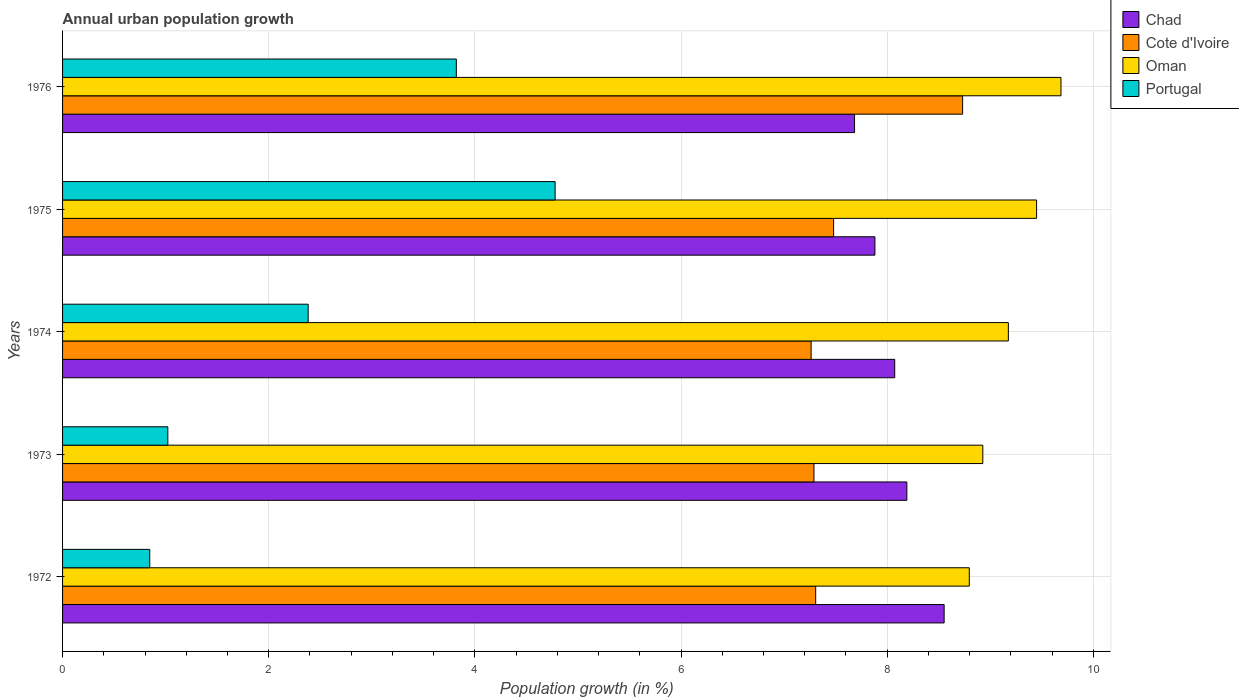How many different coloured bars are there?
Provide a short and direct response. 4. How many bars are there on the 3rd tick from the top?
Your answer should be very brief. 4. In how many cases, is the number of bars for a given year not equal to the number of legend labels?
Keep it short and to the point. 0. What is the percentage of urban population growth in Chad in 1973?
Your response must be concise. 8.19. Across all years, what is the maximum percentage of urban population growth in Cote d'Ivoire?
Your answer should be very brief. 8.73. Across all years, what is the minimum percentage of urban population growth in Chad?
Give a very brief answer. 7.68. In which year was the percentage of urban population growth in Cote d'Ivoire maximum?
Give a very brief answer. 1976. In which year was the percentage of urban population growth in Portugal minimum?
Your answer should be compact. 1972. What is the total percentage of urban population growth in Chad in the graph?
Give a very brief answer. 40.38. What is the difference between the percentage of urban population growth in Chad in 1972 and that in 1976?
Make the answer very short. 0.87. What is the difference between the percentage of urban population growth in Cote d'Ivoire in 1973 and the percentage of urban population growth in Chad in 1975?
Make the answer very short. -0.59. What is the average percentage of urban population growth in Chad per year?
Make the answer very short. 8.08. In the year 1974, what is the difference between the percentage of urban population growth in Cote d'Ivoire and percentage of urban population growth in Oman?
Your answer should be very brief. -1.91. In how many years, is the percentage of urban population growth in Oman greater than 7.2 %?
Give a very brief answer. 5. What is the ratio of the percentage of urban population growth in Oman in 1975 to that in 1976?
Offer a terse response. 0.98. Is the percentage of urban population growth in Oman in 1972 less than that in 1976?
Ensure brevity in your answer.  Yes. What is the difference between the highest and the second highest percentage of urban population growth in Portugal?
Your answer should be very brief. 0.96. What is the difference between the highest and the lowest percentage of urban population growth in Portugal?
Give a very brief answer. 3.93. Is the sum of the percentage of urban population growth in Portugal in 1972 and 1973 greater than the maximum percentage of urban population growth in Chad across all years?
Make the answer very short. No. What does the 3rd bar from the top in 1976 represents?
Ensure brevity in your answer.  Cote d'Ivoire. What does the 4th bar from the bottom in 1974 represents?
Provide a succinct answer. Portugal. Are all the bars in the graph horizontal?
Your response must be concise. Yes. How many years are there in the graph?
Your answer should be very brief. 5. Are the values on the major ticks of X-axis written in scientific E-notation?
Your answer should be very brief. No. Does the graph contain any zero values?
Keep it short and to the point. No. Does the graph contain grids?
Your answer should be compact. Yes. How many legend labels are there?
Your answer should be compact. 4. How are the legend labels stacked?
Provide a short and direct response. Vertical. What is the title of the graph?
Make the answer very short. Annual urban population growth. What is the label or title of the X-axis?
Make the answer very short. Population growth (in %). What is the Population growth (in %) of Chad in 1972?
Make the answer very short. 8.55. What is the Population growth (in %) of Cote d'Ivoire in 1972?
Offer a very short reply. 7.31. What is the Population growth (in %) in Oman in 1972?
Keep it short and to the point. 8.8. What is the Population growth (in %) in Portugal in 1972?
Make the answer very short. 0.85. What is the Population growth (in %) of Chad in 1973?
Your response must be concise. 8.19. What is the Population growth (in %) of Cote d'Ivoire in 1973?
Your response must be concise. 7.29. What is the Population growth (in %) in Oman in 1973?
Provide a succinct answer. 8.93. What is the Population growth (in %) in Portugal in 1973?
Provide a succinct answer. 1.02. What is the Population growth (in %) of Chad in 1974?
Your answer should be very brief. 8.07. What is the Population growth (in %) in Cote d'Ivoire in 1974?
Offer a very short reply. 7.26. What is the Population growth (in %) in Oman in 1974?
Your response must be concise. 9.18. What is the Population growth (in %) of Portugal in 1974?
Your answer should be very brief. 2.38. What is the Population growth (in %) of Chad in 1975?
Make the answer very short. 7.88. What is the Population growth (in %) in Cote d'Ivoire in 1975?
Offer a very short reply. 7.48. What is the Population growth (in %) of Oman in 1975?
Your response must be concise. 9.45. What is the Population growth (in %) in Portugal in 1975?
Make the answer very short. 4.78. What is the Population growth (in %) in Chad in 1976?
Give a very brief answer. 7.68. What is the Population growth (in %) in Cote d'Ivoire in 1976?
Give a very brief answer. 8.73. What is the Population growth (in %) of Oman in 1976?
Ensure brevity in your answer.  9.69. What is the Population growth (in %) in Portugal in 1976?
Provide a short and direct response. 3.82. Across all years, what is the maximum Population growth (in %) of Chad?
Offer a terse response. 8.55. Across all years, what is the maximum Population growth (in %) of Cote d'Ivoire?
Provide a short and direct response. 8.73. Across all years, what is the maximum Population growth (in %) in Oman?
Your answer should be compact. 9.69. Across all years, what is the maximum Population growth (in %) of Portugal?
Your answer should be compact. 4.78. Across all years, what is the minimum Population growth (in %) in Chad?
Offer a terse response. 7.68. Across all years, what is the minimum Population growth (in %) in Cote d'Ivoire?
Provide a succinct answer. 7.26. Across all years, what is the minimum Population growth (in %) of Oman?
Provide a succinct answer. 8.8. Across all years, what is the minimum Population growth (in %) in Portugal?
Give a very brief answer. 0.85. What is the total Population growth (in %) of Chad in the graph?
Provide a short and direct response. 40.38. What is the total Population growth (in %) of Cote d'Ivoire in the graph?
Your response must be concise. 38.07. What is the total Population growth (in %) in Oman in the graph?
Ensure brevity in your answer.  46.04. What is the total Population growth (in %) of Portugal in the graph?
Keep it short and to the point. 12.85. What is the difference between the Population growth (in %) in Chad in 1972 and that in 1973?
Keep it short and to the point. 0.36. What is the difference between the Population growth (in %) of Cote d'Ivoire in 1972 and that in 1973?
Offer a terse response. 0.02. What is the difference between the Population growth (in %) in Oman in 1972 and that in 1973?
Keep it short and to the point. -0.13. What is the difference between the Population growth (in %) in Portugal in 1972 and that in 1973?
Offer a terse response. -0.18. What is the difference between the Population growth (in %) in Chad in 1972 and that in 1974?
Offer a very short reply. 0.48. What is the difference between the Population growth (in %) of Cote d'Ivoire in 1972 and that in 1974?
Your answer should be very brief. 0.04. What is the difference between the Population growth (in %) in Oman in 1972 and that in 1974?
Offer a terse response. -0.38. What is the difference between the Population growth (in %) in Portugal in 1972 and that in 1974?
Offer a terse response. -1.54. What is the difference between the Population growth (in %) of Chad in 1972 and that in 1975?
Offer a very short reply. 0.67. What is the difference between the Population growth (in %) of Cote d'Ivoire in 1972 and that in 1975?
Offer a very short reply. -0.17. What is the difference between the Population growth (in %) of Oman in 1972 and that in 1975?
Offer a very short reply. -0.65. What is the difference between the Population growth (in %) in Portugal in 1972 and that in 1975?
Give a very brief answer. -3.93. What is the difference between the Population growth (in %) of Chad in 1972 and that in 1976?
Your answer should be compact. 0.87. What is the difference between the Population growth (in %) of Cote d'Ivoire in 1972 and that in 1976?
Give a very brief answer. -1.43. What is the difference between the Population growth (in %) in Oman in 1972 and that in 1976?
Provide a short and direct response. -0.89. What is the difference between the Population growth (in %) in Portugal in 1972 and that in 1976?
Your response must be concise. -2.97. What is the difference between the Population growth (in %) in Chad in 1973 and that in 1974?
Ensure brevity in your answer.  0.12. What is the difference between the Population growth (in %) of Cote d'Ivoire in 1973 and that in 1974?
Your response must be concise. 0.03. What is the difference between the Population growth (in %) in Oman in 1973 and that in 1974?
Offer a very short reply. -0.25. What is the difference between the Population growth (in %) in Portugal in 1973 and that in 1974?
Give a very brief answer. -1.36. What is the difference between the Population growth (in %) of Chad in 1973 and that in 1975?
Your answer should be very brief. 0.31. What is the difference between the Population growth (in %) in Cote d'Ivoire in 1973 and that in 1975?
Offer a terse response. -0.19. What is the difference between the Population growth (in %) of Oman in 1973 and that in 1975?
Ensure brevity in your answer.  -0.52. What is the difference between the Population growth (in %) in Portugal in 1973 and that in 1975?
Provide a short and direct response. -3.76. What is the difference between the Population growth (in %) of Chad in 1973 and that in 1976?
Your response must be concise. 0.51. What is the difference between the Population growth (in %) of Cote d'Ivoire in 1973 and that in 1976?
Ensure brevity in your answer.  -1.44. What is the difference between the Population growth (in %) in Oman in 1973 and that in 1976?
Your answer should be compact. -0.76. What is the difference between the Population growth (in %) of Portugal in 1973 and that in 1976?
Ensure brevity in your answer.  -2.8. What is the difference between the Population growth (in %) of Chad in 1974 and that in 1975?
Ensure brevity in your answer.  0.19. What is the difference between the Population growth (in %) of Cote d'Ivoire in 1974 and that in 1975?
Your answer should be very brief. -0.22. What is the difference between the Population growth (in %) in Oman in 1974 and that in 1975?
Offer a very short reply. -0.27. What is the difference between the Population growth (in %) of Portugal in 1974 and that in 1975?
Your response must be concise. -2.4. What is the difference between the Population growth (in %) of Chad in 1974 and that in 1976?
Keep it short and to the point. 0.39. What is the difference between the Population growth (in %) in Cote d'Ivoire in 1974 and that in 1976?
Your answer should be very brief. -1.47. What is the difference between the Population growth (in %) of Oman in 1974 and that in 1976?
Your response must be concise. -0.51. What is the difference between the Population growth (in %) in Portugal in 1974 and that in 1976?
Offer a terse response. -1.44. What is the difference between the Population growth (in %) in Chad in 1975 and that in 1976?
Keep it short and to the point. 0.2. What is the difference between the Population growth (in %) in Cote d'Ivoire in 1975 and that in 1976?
Offer a very short reply. -1.25. What is the difference between the Population growth (in %) in Oman in 1975 and that in 1976?
Offer a terse response. -0.24. What is the difference between the Population growth (in %) of Portugal in 1975 and that in 1976?
Provide a short and direct response. 0.96. What is the difference between the Population growth (in %) of Chad in 1972 and the Population growth (in %) of Cote d'Ivoire in 1973?
Make the answer very short. 1.26. What is the difference between the Population growth (in %) of Chad in 1972 and the Population growth (in %) of Oman in 1973?
Make the answer very short. -0.38. What is the difference between the Population growth (in %) in Chad in 1972 and the Population growth (in %) in Portugal in 1973?
Keep it short and to the point. 7.53. What is the difference between the Population growth (in %) in Cote d'Ivoire in 1972 and the Population growth (in %) in Oman in 1973?
Your response must be concise. -1.62. What is the difference between the Population growth (in %) of Cote d'Ivoire in 1972 and the Population growth (in %) of Portugal in 1973?
Offer a terse response. 6.29. What is the difference between the Population growth (in %) of Oman in 1972 and the Population growth (in %) of Portugal in 1973?
Your answer should be compact. 7.78. What is the difference between the Population growth (in %) of Chad in 1972 and the Population growth (in %) of Cote d'Ivoire in 1974?
Give a very brief answer. 1.29. What is the difference between the Population growth (in %) in Chad in 1972 and the Population growth (in %) in Oman in 1974?
Provide a short and direct response. -0.62. What is the difference between the Population growth (in %) in Chad in 1972 and the Population growth (in %) in Portugal in 1974?
Your answer should be compact. 6.17. What is the difference between the Population growth (in %) in Cote d'Ivoire in 1972 and the Population growth (in %) in Oman in 1974?
Provide a succinct answer. -1.87. What is the difference between the Population growth (in %) in Cote d'Ivoire in 1972 and the Population growth (in %) in Portugal in 1974?
Ensure brevity in your answer.  4.92. What is the difference between the Population growth (in %) of Oman in 1972 and the Population growth (in %) of Portugal in 1974?
Offer a terse response. 6.41. What is the difference between the Population growth (in %) in Chad in 1972 and the Population growth (in %) in Cote d'Ivoire in 1975?
Keep it short and to the point. 1.07. What is the difference between the Population growth (in %) of Chad in 1972 and the Population growth (in %) of Oman in 1975?
Offer a very short reply. -0.9. What is the difference between the Population growth (in %) in Chad in 1972 and the Population growth (in %) in Portugal in 1975?
Give a very brief answer. 3.77. What is the difference between the Population growth (in %) of Cote d'Ivoire in 1972 and the Population growth (in %) of Oman in 1975?
Offer a terse response. -2.14. What is the difference between the Population growth (in %) in Cote d'Ivoire in 1972 and the Population growth (in %) in Portugal in 1975?
Give a very brief answer. 2.53. What is the difference between the Population growth (in %) in Oman in 1972 and the Population growth (in %) in Portugal in 1975?
Give a very brief answer. 4.02. What is the difference between the Population growth (in %) in Chad in 1972 and the Population growth (in %) in Cote d'Ivoire in 1976?
Provide a succinct answer. -0.18. What is the difference between the Population growth (in %) in Chad in 1972 and the Population growth (in %) in Oman in 1976?
Offer a very short reply. -1.13. What is the difference between the Population growth (in %) of Chad in 1972 and the Population growth (in %) of Portugal in 1976?
Keep it short and to the point. 4.73. What is the difference between the Population growth (in %) in Cote d'Ivoire in 1972 and the Population growth (in %) in Oman in 1976?
Provide a succinct answer. -2.38. What is the difference between the Population growth (in %) in Cote d'Ivoire in 1972 and the Population growth (in %) in Portugal in 1976?
Your response must be concise. 3.49. What is the difference between the Population growth (in %) of Oman in 1972 and the Population growth (in %) of Portugal in 1976?
Keep it short and to the point. 4.98. What is the difference between the Population growth (in %) in Chad in 1973 and the Population growth (in %) in Cote d'Ivoire in 1974?
Offer a very short reply. 0.93. What is the difference between the Population growth (in %) in Chad in 1973 and the Population growth (in %) in Oman in 1974?
Keep it short and to the point. -0.98. What is the difference between the Population growth (in %) of Chad in 1973 and the Population growth (in %) of Portugal in 1974?
Provide a succinct answer. 5.81. What is the difference between the Population growth (in %) of Cote d'Ivoire in 1973 and the Population growth (in %) of Oman in 1974?
Give a very brief answer. -1.89. What is the difference between the Population growth (in %) in Cote d'Ivoire in 1973 and the Population growth (in %) in Portugal in 1974?
Your answer should be very brief. 4.91. What is the difference between the Population growth (in %) in Oman in 1973 and the Population growth (in %) in Portugal in 1974?
Offer a terse response. 6.55. What is the difference between the Population growth (in %) in Chad in 1973 and the Population growth (in %) in Cote d'Ivoire in 1975?
Offer a terse response. 0.71. What is the difference between the Population growth (in %) of Chad in 1973 and the Population growth (in %) of Oman in 1975?
Your answer should be very brief. -1.26. What is the difference between the Population growth (in %) in Chad in 1973 and the Population growth (in %) in Portugal in 1975?
Keep it short and to the point. 3.41. What is the difference between the Population growth (in %) in Cote d'Ivoire in 1973 and the Population growth (in %) in Oman in 1975?
Provide a short and direct response. -2.16. What is the difference between the Population growth (in %) of Cote d'Ivoire in 1973 and the Population growth (in %) of Portugal in 1975?
Ensure brevity in your answer.  2.51. What is the difference between the Population growth (in %) of Oman in 1973 and the Population growth (in %) of Portugal in 1975?
Give a very brief answer. 4.15. What is the difference between the Population growth (in %) in Chad in 1973 and the Population growth (in %) in Cote d'Ivoire in 1976?
Provide a short and direct response. -0.54. What is the difference between the Population growth (in %) in Chad in 1973 and the Population growth (in %) in Oman in 1976?
Give a very brief answer. -1.5. What is the difference between the Population growth (in %) in Chad in 1973 and the Population growth (in %) in Portugal in 1976?
Offer a terse response. 4.37. What is the difference between the Population growth (in %) of Cote d'Ivoire in 1973 and the Population growth (in %) of Oman in 1976?
Keep it short and to the point. -2.4. What is the difference between the Population growth (in %) of Cote d'Ivoire in 1973 and the Population growth (in %) of Portugal in 1976?
Your answer should be very brief. 3.47. What is the difference between the Population growth (in %) of Oman in 1973 and the Population growth (in %) of Portugal in 1976?
Keep it short and to the point. 5.11. What is the difference between the Population growth (in %) of Chad in 1974 and the Population growth (in %) of Cote d'Ivoire in 1975?
Your response must be concise. 0.59. What is the difference between the Population growth (in %) in Chad in 1974 and the Population growth (in %) in Oman in 1975?
Make the answer very short. -1.38. What is the difference between the Population growth (in %) in Chad in 1974 and the Population growth (in %) in Portugal in 1975?
Give a very brief answer. 3.29. What is the difference between the Population growth (in %) of Cote d'Ivoire in 1974 and the Population growth (in %) of Oman in 1975?
Your answer should be compact. -2.19. What is the difference between the Population growth (in %) in Cote d'Ivoire in 1974 and the Population growth (in %) in Portugal in 1975?
Offer a very short reply. 2.48. What is the difference between the Population growth (in %) of Oman in 1974 and the Population growth (in %) of Portugal in 1975?
Make the answer very short. 4.4. What is the difference between the Population growth (in %) of Chad in 1974 and the Population growth (in %) of Cote d'Ivoire in 1976?
Your response must be concise. -0.66. What is the difference between the Population growth (in %) of Chad in 1974 and the Population growth (in %) of Oman in 1976?
Offer a terse response. -1.61. What is the difference between the Population growth (in %) of Chad in 1974 and the Population growth (in %) of Portugal in 1976?
Make the answer very short. 4.25. What is the difference between the Population growth (in %) of Cote d'Ivoire in 1974 and the Population growth (in %) of Oman in 1976?
Ensure brevity in your answer.  -2.42. What is the difference between the Population growth (in %) in Cote d'Ivoire in 1974 and the Population growth (in %) in Portugal in 1976?
Keep it short and to the point. 3.44. What is the difference between the Population growth (in %) in Oman in 1974 and the Population growth (in %) in Portugal in 1976?
Offer a very short reply. 5.36. What is the difference between the Population growth (in %) of Chad in 1975 and the Population growth (in %) of Cote d'Ivoire in 1976?
Give a very brief answer. -0.85. What is the difference between the Population growth (in %) in Chad in 1975 and the Population growth (in %) in Oman in 1976?
Provide a succinct answer. -1.8. What is the difference between the Population growth (in %) of Chad in 1975 and the Population growth (in %) of Portugal in 1976?
Your response must be concise. 4.06. What is the difference between the Population growth (in %) in Cote d'Ivoire in 1975 and the Population growth (in %) in Oman in 1976?
Provide a short and direct response. -2.21. What is the difference between the Population growth (in %) in Cote d'Ivoire in 1975 and the Population growth (in %) in Portugal in 1976?
Make the answer very short. 3.66. What is the difference between the Population growth (in %) in Oman in 1975 and the Population growth (in %) in Portugal in 1976?
Ensure brevity in your answer.  5.63. What is the average Population growth (in %) in Chad per year?
Ensure brevity in your answer.  8.08. What is the average Population growth (in %) in Cote d'Ivoire per year?
Your answer should be very brief. 7.61. What is the average Population growth (in %) of Oman per year?
Provide a succinct answer. 9.21. What is the average Population growth (in %) of Portugal per year?
Ensure brevity in your answer.  2.57. In the year 1972, what is the difference between the Population growth (in %) in Chad and Population growth (in %) in Cote d'Ivoire?
Your answer should be compact. 1.25. In the year 1972, what is the difference between the Population growth (in %) of Chad and Population growth (in %) of Oman?
Provide a short and direct response. -0.24. In the year 1972, what is the difference between the Population growth (in %) in Chad and Population growth (in %) in Portugal?
Offer a terse response. 7.71. In the year 1972, what is the difference between the Population growth (in %) in Cote d'Ivoire and Population growth (in %) in Oman?
Ensure brevity in your answer.  -1.49. In the year 1972, what is the difference between the Population growth (in %) in Cote d'Ivoire and Population growth (in %) in Portugal?
Give a very brief answer. 6.46. In the year 1972, what is the difference between the Population growth (in %) in Oman and Population growth (in %) in Portugal?
Your response must be concise. 7.95. In the year 1973, what is the difference between the Population growth (in %) in Chad and Population growth (in %) in Cote d'Ivoire?
Ensure brevity in your answer.  0.9. In the year 1973, what is the difference between the Population growth (in %) in Chad and Population growth (in %) in Oman?
Keep it short and to the point. -0.74. In the year 1973, what is the difference between the Population growth (in %) in Chad and Population growth (in %) in Portugal?
Offer a very short reply. 7.17. In the year 1973, what is the difference between the Population growth (in %) in Cote d'Ivoire and Population growth (in %) in Oman?
Give a very brief answer. -1.64. In the year 1973, what is the difference between the Population growth (in %) of Cote d'Ivoire and Population growth (in %) of Portugal?
Ensure brevity in your answer.  6.27. In the year 1973, what is the difference between the Population growth (in %) in Oman and Population growth (in %) in Portugal?
Keep it short and to the point. 7.91. In the year 1974, what is the difference between the Population growth (in %) of Chad and Population growth (in %) of Cote d'Ivoire?
Your response must be concise. 0.81. In the year 1974, what is the difference between the Population growth (in %) of Chad and Population growth (in %) of Oman?
Keep it short and to the point. -1.1. In the year 1974, what is the difference between the Population growth (in %) in Chad and Population growth (in %) in Portugal?
Your answer should be very brief. 5.69. In the year 1974, what is the difference between the Population growth (in %) of Cote d'Ivoire and Population growth (in %) of Oman?
Provide a short and direct response. -1.91. In the year 1974, what is the difference between the Population growth (in %) in Cote d'Ivoire and Population growth (in %) in Portugal?
Keep it short and to the point. 4.88. In the year 1974, what is the difference between the Population growth (in %) in Oman and Population growth (in %) in Portugal?
Your response must be concise. 6.79. In the year 1975, what is the difference between the Population growth (in %) of Chad and Population growth (in %) of Cote d'Ivoire?
Keep it short and to the point. 0.4. In the year 1975, what is the difference between the Population growth (in %) in Chad and Population growth (in %) in Oman?
Offer a very short reply. -1.57. In the year 1975, what is the difference between the Population growth (in %) in Chad and Population growth (in %) in Portugal?
Your response must be concise. 3.1. In the year 1975, what is the difference between the Population growth (in %) of Cote d'Ivoire and Population growth (in %) of Oman?
Provide a succinct answer. -1.97. In the year 1975, what is the difference between the Population growth (in %) in Cote d'Ivoire and Population growth (in %) in Portugal?
Provide a short and direct response. 2.7. In the year 1975, what is the difference between the Population growth (in %) of Oman and Population growth (in %) of Portugal?
Offer a very short reply. 4.67. In the year 1976, what is the difference between the Population growth (in %) in Chad and Population growth (in %) in Cote d'Ivoire?
Your response must be concise. -1.05. In the year 1976, what is the difference between the Population growth (in %) of Chad and Population growth (in %) of Oman?
Keep it short and to the point. -2. In the year 1976, what is the difference between the Population growth (in %) of Chad and Population growth (in %) of Portugal?
Your answer should be very brief. 3.86. In the year 1976, what is the difference between the Population growth (in %) of Cote d'Ivoire and Population growth (in %) of Oman?
Offer a very short reply. -0.95. In the year 1976, what is the difference between the Population growth (in %) in Cote d'Ivoire and Population growth (in %) in Portugal?
Offer a very short reply. 4.91. In the year 1976, what is the difference between the Population growth (in %) of Oman and Population growth (in %) of Portugal?
Give a very brief answer. 5.87. What is the ratio of the Population growth (in %) of Chad in 1972 to that in 1973?
Your answer should be very brief. 1.04. What is the ratio of the Population growth (in %) in Cote d'Ivoire in 1972 to that in 1973?
Your answer should be compact. 1. What is the ratio of the Population growth (in %) of Portugal in 1972 to that in 1973?
Provide a succinct answer. 0.83. What is the ratio of the Population growth (in %) in Chad in 1972 to that in 1974?
Give a very brief answer. 1.06. What is the ratio of the Population growth (in %) in Cote d'Ivoire in 1972 to that in 1974?
Your answer should be very brief. 1.01. What is the ratio of the Population growth (in %) in Oman in 1972 to that in 1974?
Offer a very short reply. 0.96. What is the ratio of the Population growth (in %) of Portugal in 1972 to that in 1974?
Make the answer very short. 0.35. What is the ratio of the Population growth (in %) of Chad in 1972 to that in 1975?
Give a very brief answer. 1.09. What is the ratio of the Population growth (in %) of Cote d'Ivoire in 1972 to that in 1975?
Offer a very short reply. 0.98. What is the ratio of the Population growth (in %) of Oman in 1972 to that in 1975?
Keep it short and to the point. 0.93. What is the ratio of the Population growth (in %) of Portugal in 1972 to that in 1975?
Give a very brief answer. 0.18. What is the ratio of the Population growth (in %) of Chad in 1972 to that in 1976?
Provide a succinct answer. 1.11. What is the ratio of the Population growth (in %) in Cote d'Ivoire in 1972 to that in 1976?
Provide a short and direct response. 0.84. What is the ratio of the Population growth (in %) in Oman in 1972 to that in 1976?
Make the answer very short. 0.91. What is the ratio of the Population growth (in %) of Portugal in 1972 to that in 1976?
Your response must be concise. 0.22. What is the ratio of the Population growth (in %) in Chad in 1973 to that in 1974?
Offer a terse response. 1.01. What is the ratio of the Population growth (in %) of Cote d'Ivoire in 1973 to that in 1974?
Keep it short and to the point. 1. What is the ratio of the Population growth (in %) of Oman in 1973 to that in 1974?
Give a very brief answer. 0.97. What is the ratio of the Population growth (in %) in Portugal in 1973 to that in 1974?
Your answer should be very brief. 0.43. What is the ratio of the Population growth (in %) of Chad in 1973 to that in 1975?
Provide a succinct answer. 1.04. What is the ratio of the Population growth (in %) of Cote d'Ivoire in 1973 to that in 1975?
Make the answer very short. 0.97. What is the ratio of the Population growth (in %) of Oman in 1973 to that in 1975?
Your answer should be compact. 0.94. What is the ratio of the Population growth (in %) in Portugal in 1973 to that in 1975?
Keep it short and to the point. 0.21. What is the ratio of the Population growth (in %) of Chad in 1973 to that in 1976?
Your response must be concise. 1.07. What is the ratio of the Population growth (in %) of Cote d'Ivoire in 1973 to that in 1976?
Keep it short and to the point. 0.83. What is the ratio of the Population growth (in %) of Oman in 1973 to that in 1976?
Ensure brevity in your answer.  0.92. What is the ratio of the Population growth (in %) in Portugal in 1973 to that in 1976?
Your response must be concise. 0.27. What is the ratio of the Population growth (in %) of Chad in 1974 to that in 1975?
Offer a very short reply. 1.02. What is the ratio of the Population growth (in %) in Cote d'Ivoire in 1974 to that in 1975?
Offer a terse response. 0.97. What is the ratio of the Population growth (in %) in Portugal in 1974 to that in 1975?
Make the answer very short. 0.5. What is the ratio of the Population growth (in %) in Chad in 1974 to that in 1976?
Keep it short and to the point. 1.05. What is the ratio of the Population growth (in %) of Cote d'Ivoire in 1974 to that in 1976?
Ensure brevity in your answer.  0.83. What is the ratio of the Population growth (in %) in Oman in 1974 to that in 1976?
Give a very brief answer. 0.95. What is the ratio of the Population growth (in %) in Portugal in 1974 to that in 1976?
Give a very brief answer. 0.62. What is the ratio of the Population growth (in %) of Chad in 1975 to that in 1976?
Provide a succinct answer. 1.03. What is the ratio of the Population growth (in %) of Cote d'Ivoire in 1975 to that in 1976?
Keep it short and to the point. 0.86. What is the ratio of the Population growth (in %) in Oman in 1975 to that in 1976?
Your answer should be very brief. 0.98. What is the ratio of the Population growth (in %) of Portugal in 1975 to that in 1976?
Ensure brevity in your answer.  1.25. What is the difference between the highest and the second highest Population growth (in %) in Chad?
Make the answer very short. 0.36. What is the difference between the highest and the second highest Population growth (in %) in Cote d'Ivoire?
Your answer should be compact. 1.25. What is the difference between the highest and the second highest Population growth (in %) of Oman?
Provide a succinct answer. 0.24. What is the difference between the highest and the second highest Population growth (in %) of Portugal?
Your response must be concise. 0.96. What is the difference between the highest and the lowest Population growth (in %) of Chad?
Keep it short and to the point. 0.87. What is the difference between the highest and the lowest Population growth (in %) in Cote d'Ivoire?
Offer a very short reply. 1.47. What is the difference between the highest and the lowest Population growth (in %) of Oman?
Offer a terse response. 0.89. What is the difference between the highest and the lowest Population growth (in %) of Portugal?
Offer a very short reply. 3.93. 